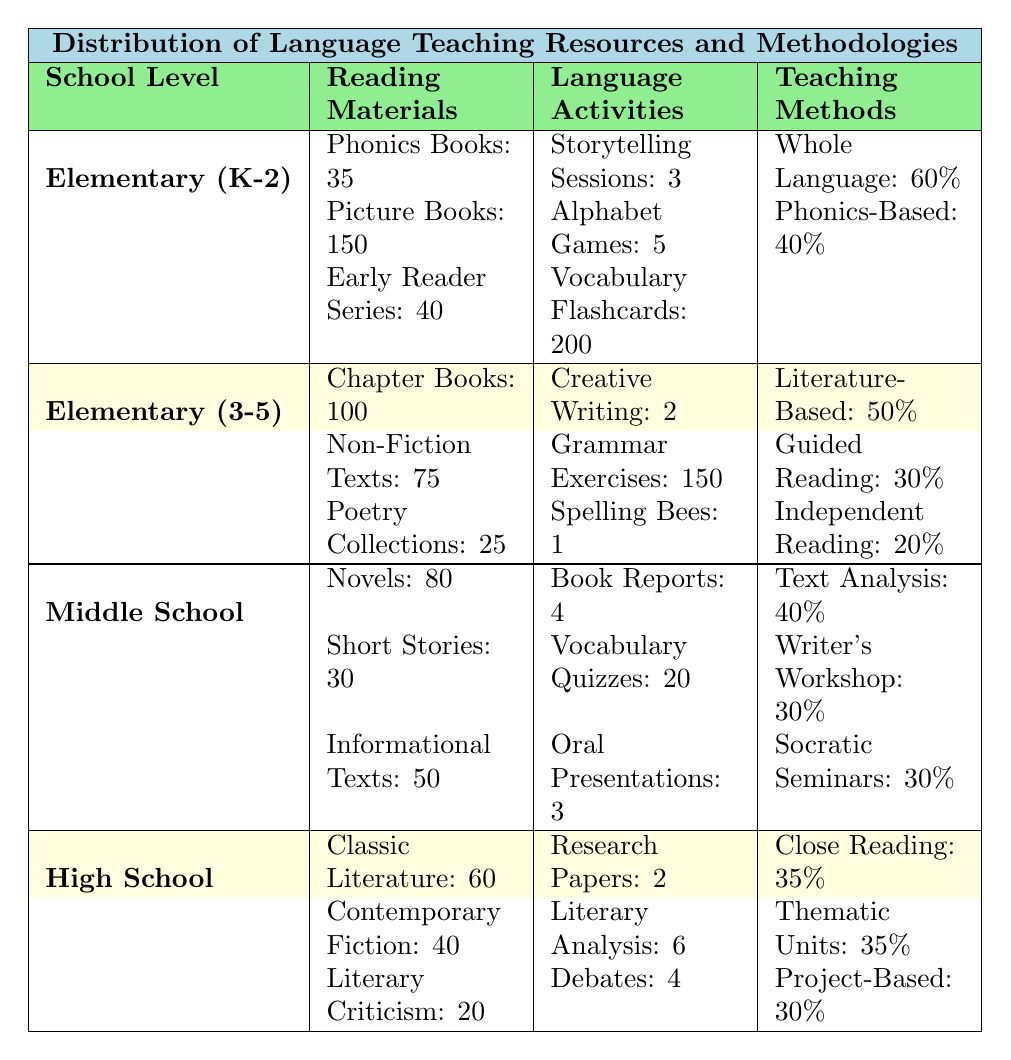What is the total number of phonics books available in Kindergarten to Grade 2? The table lists that there are 35 phonics books for Kindergarten to Grade 2. Therefore, the total is simply 35.
Answer: 35 How many total reading materials are provided for Grade 3 to Grade 5? The reading materials for Grade 3 to Grade 5 include Chapter Books (100), Non-Fiction Texts (75), and Poetry Collections (25). Adding these gives 100 + 75 + 25 = 200.
Answer: 200 Is the number of vocabulary flashcards greater than the number of storytelling sessions in Kindergarten to Grade 2? The table indicates 200 vocabulary flashcards and 3 storytelling sessions. Since 200 is greater than 3, the statement is true.
Answer: Yes What percentage of the teaching methods in Elementary (K-2) is based on the Whole Language Approach? The table states that the Whole Language Approach constitutes 60% of the teaching methods in Elementary (K-2). This is a direct retrieval from the data.
Answer: 60% What is the average number of language activities across all school levels? For Elementary (K-2), there are 3 + 5 + 200 = 208 activities; for Elementary (3-5), there are 2 + 150 + 1 = 153; for Middle School, 4 + 20 + 3 = 27; for High School, 2 + 6 + 4 = 12. The total is 208 + 153 + 27 + 12 = 400. There are 4 levels, so the average is 400 / 4 = 100.
Answer: 100 How does the proportion of poetry collections in Elementary (3-5) compare to novels in Middle School? In Elementary (3-5), there are 25 poetry collections, and in Middle School, there are 80 novels. To compare, 25 is less than 80, so the poetry collections are a smaller proportion than the novels.
Answer: Smaller proportion How many more language activities are conducted in Elementary (3-5) compared to High School? In Elementary (3-5), the total language activities are 2 + 150 + 1 = 153, and in High School, they are 2 + 6 + 4 = 12. The difference is 153 - 12 = 141.
Answer: 141 What is the combined total of literary analysis essays and debates in High School? The total for High School is 6 literary analysis essays plus 4 debates, which sums up to 6 + 4 = 10.
Answer: 10 In what school level is the method "Independent Reading" primarily utilized? The method "Independent Reading" is specifically mentioned under the teaching methods for Elementary (3-5), where it accounts for 20%. This makes it primarily utilized in Elementary (3-5).
Answer: Elementary (3-5) Which school level utilizes the highest number of vocabulary quizzes, and how many are there? The table shows 20 vocabulary quizzes in Middle School, which is the highest compared to others as Elementary (K-2) and High School have no listed quizzes.
Answer: Middle School, 20 What is the highest number of reading materials found in any school level, and what type are they? The highest number of reading materials is 150 picture books in Kindergarten to Grade 2. This exceeds other categories listed in any school level.
Answer: 150 picture books in Kindergarten to Grade 2 